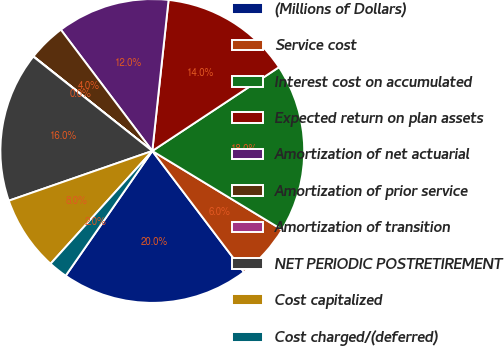Convert chart to OTSL. <chart><loc_0><loc_0><loc_500><loc_500><pie_chart><fcel>(Millions of Dollars)<fcel>Service cost<fcel>Interest cost on accumulated<fcel>Expected return on plan assets<fcel>Amortization of net actuarial<fcel>Amortization of prior service<fcel>Amortization of transition<fcel>NET PERIODIC POSTRETIREMENT<fcel>Cost capitalized<fcel>Cost charged/(deferred)<nl><fcel>19.97%<fcel>6.01%<fcel>17.98%<fcel>13.99%<fcel>11.99%<fcel>4.02%<fcel>0.03%<fcel>15.98%<fcel>8.01%<fcel>2.02%<nl></chart> 